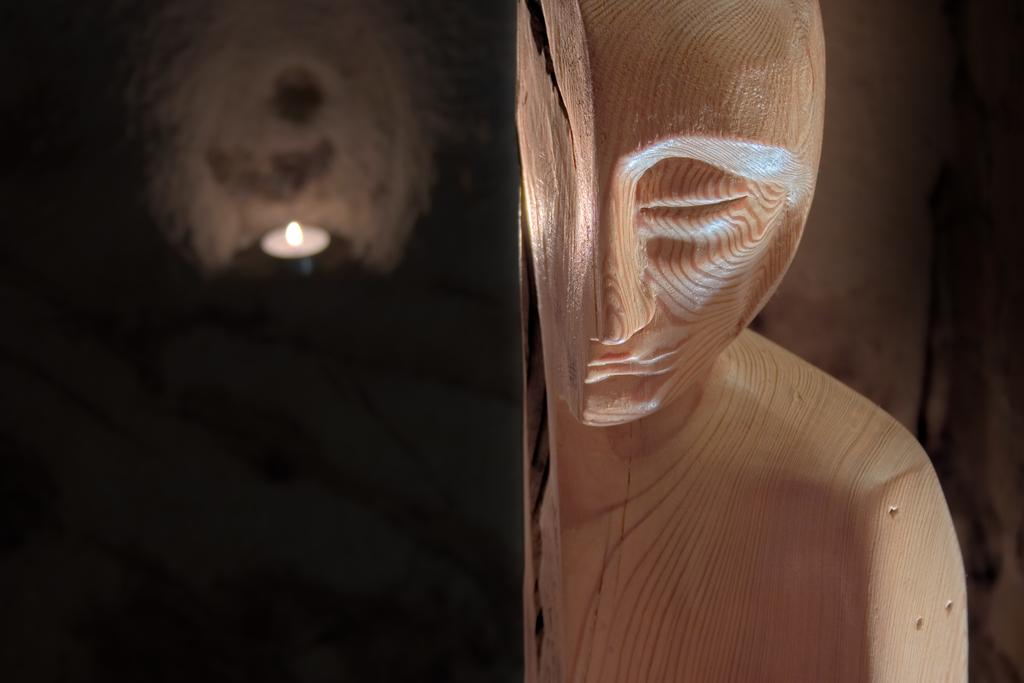What can be seen on the right side of the image? There is a wooden statue on the right side of the image. How would you describe the left side of the image? The left side of the image has a blurry background. Is there a cushion on the wooden statue in the image? There is no mention of a cushion in the image, so we cannot determine if it is present or not. 